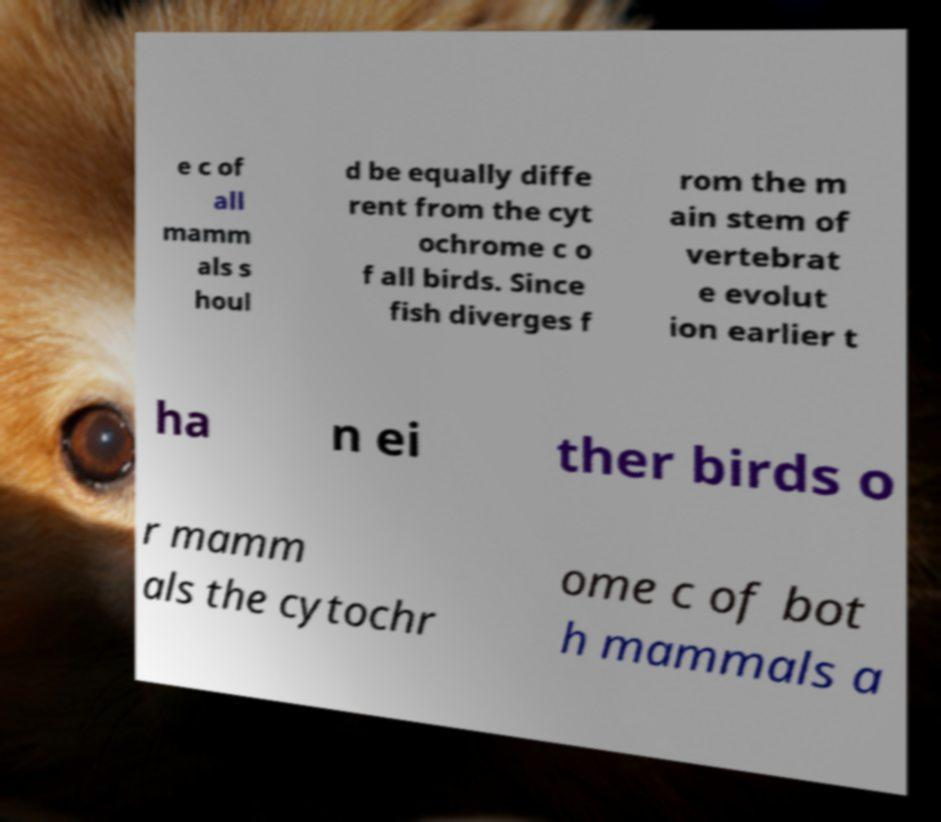Can you read and provide the text displayed in the image?This photo seems to have some interesting text. Can you extract and type it out for me? e c of all mamm als s houl d be equally diffe rent from the cyt ochrome c o f all birds. Since fish diverges f rom the m ain stem of vertebrat e evolut ion earlier t ha n ei ther birds o r mamm als the cytochr ome c of bot h mammals a 